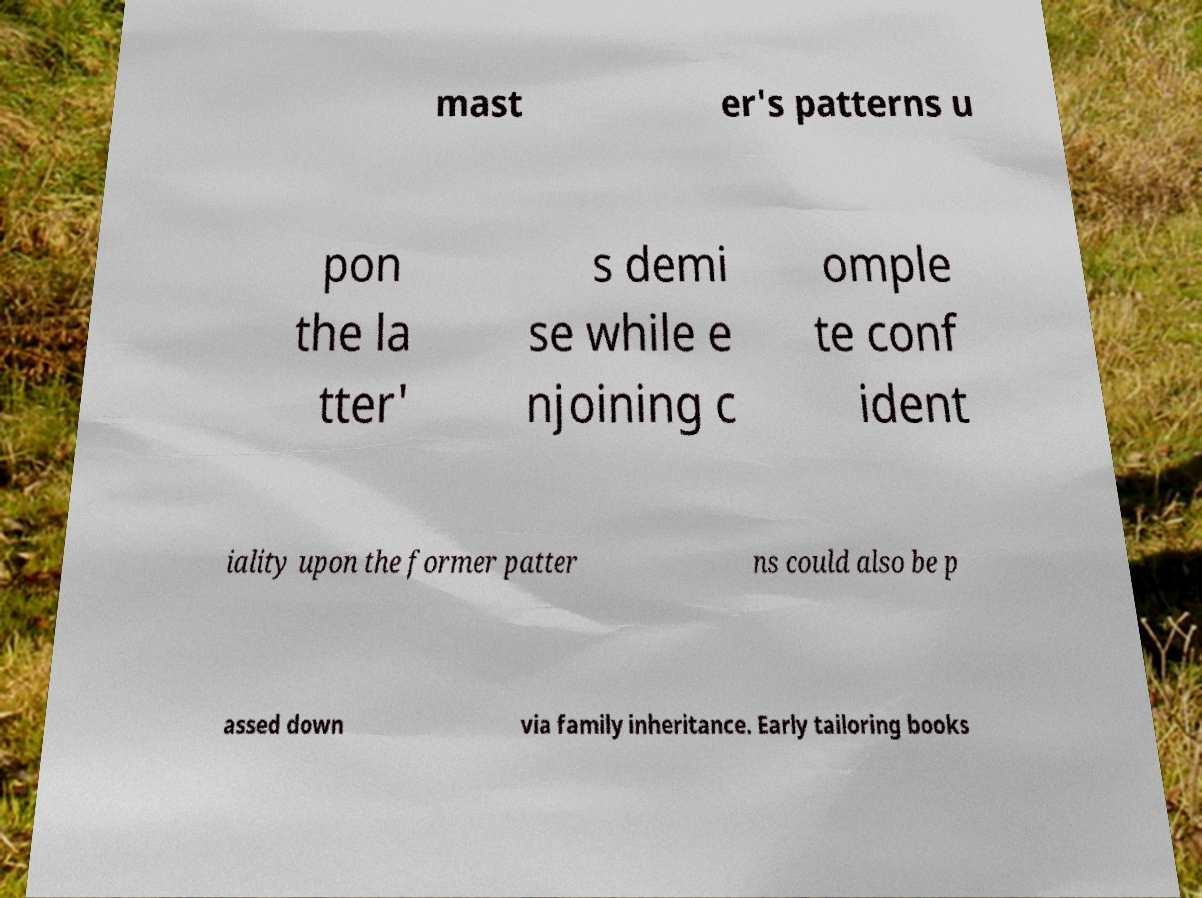Could you extract and type out the text from this image? mast er's patterns u pon the la tter' s demi se while e njoining c omple te conf ident iality upon the former patter ns could also be p assed down via family inheritance. Early tailoring books 